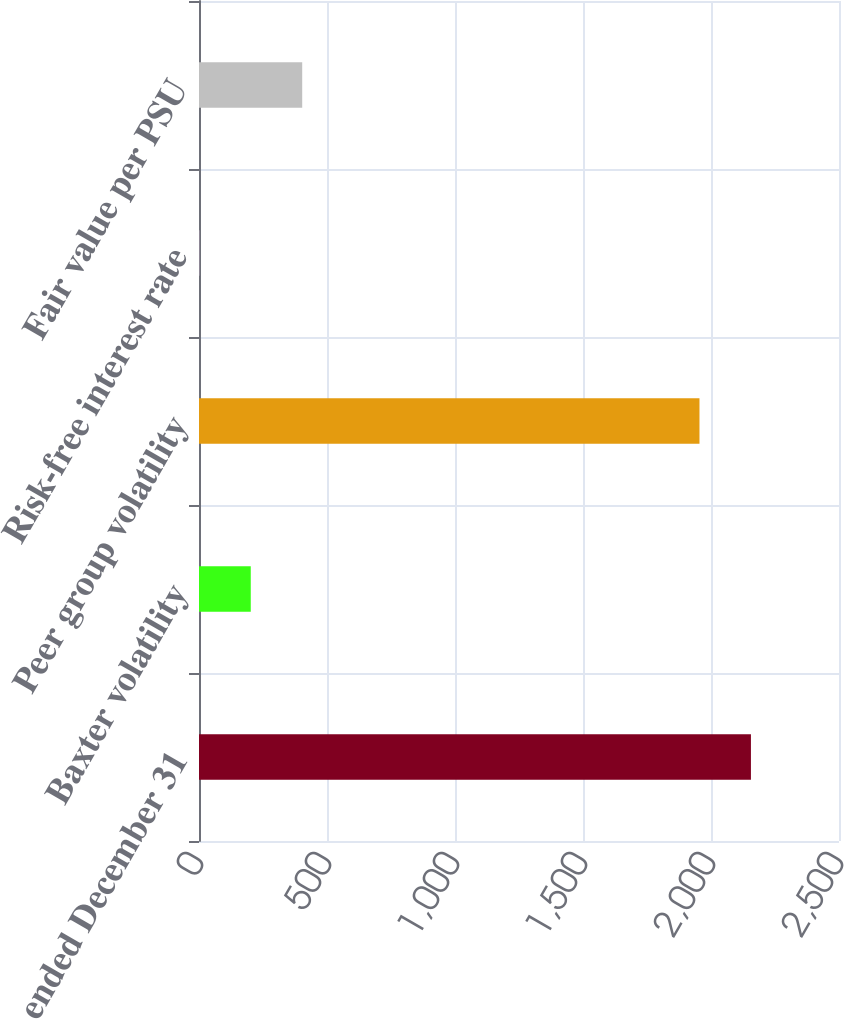Convert chart to OTSL. <chart><loc_0><loc_0><loc_500><loc_500><bar_chart><fcel>years ended December 31<fcel>Baxter volatility<fcel>Peer group volatility<fcel>Risk-free interest rate<fcel>Fair value per PSU<nl><fcel>2155.98<fcel>202.18<fcel>1955<fcel>1.2<fcel>403.16<nl></chart> 